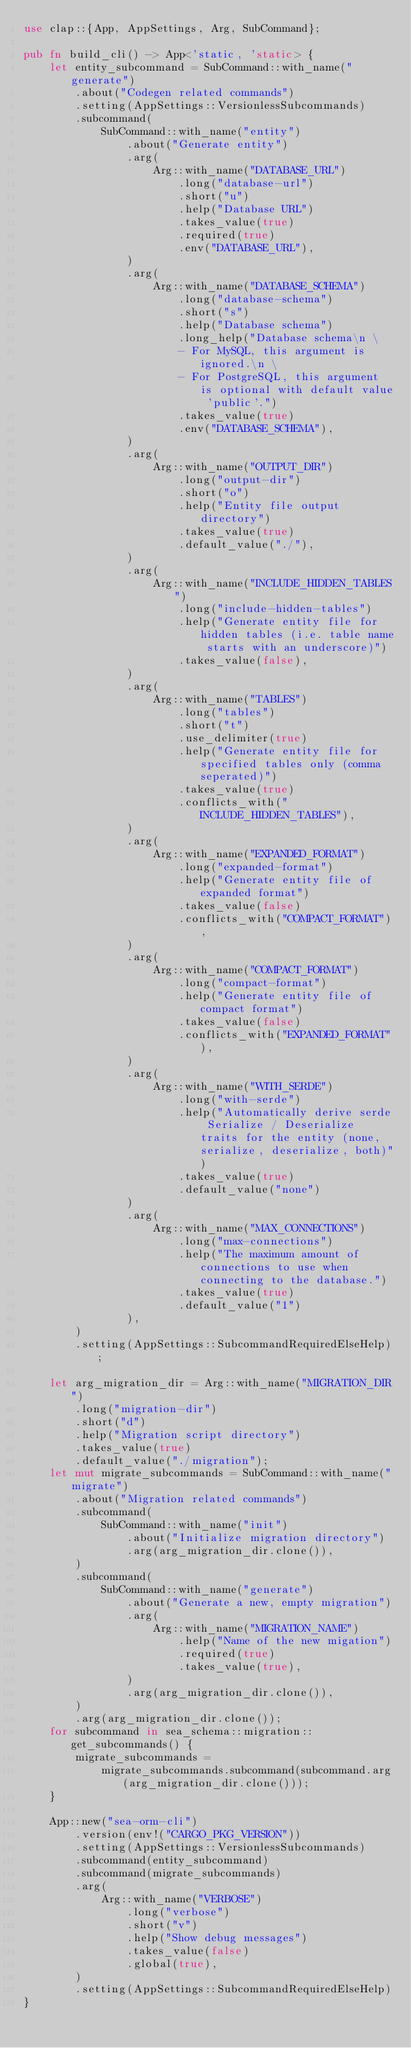Convert code to text. <code><loc_0><loc_0><loc_500><loc_500><_Rust_>use clap::{App, AppSettings, Arg, SubCommand};

pub fn build_cli() -> App<'static, 'static> {
    let entity_subcommand = SubCommand::with_name("generate")
        .about("Codegen related commands")
        .setting(AppSettings::VersionlessSubcommands)
        .subcommand(
            SubCommand::with_name("entity")
                .about("Generate entity")
                .arg(
                    Arg::with_name("DATABASE_URL")
                        .long("database-url")
                        .short("u")
                        .help("Database URL")
                        .takes_value(true)
                        .required(true)
                        .env("DATABASE_URL"),
                )
                .arg(
                    Arg::with_name("DATABASE_SCHEMA")
                        .long("database-schema")
                        .short("s")
                        .help("Database schema")
                        .long_help("Database schema\n \
                        - For MySQL, this argument is ignored.\n \
                        - For PostgreSQL, this argument is optional with default value 'public'.")
                        .takes_value(true)
                        .env("DATABASE_SCHEMA"),
                )
                .arg(
                    Arg::with_name("OUTPUT_DIR")
                        .long("output-dir")
                        .short("o")
                        .help("Entity file output directory")
                        .takes_value(true)
                        .default_value("./"),
                )
                .arg(
                    Arg::with_name("INCLUDE_HIDDEN_TABLES")
                        .long("include-hidden-tables")
                        .help("Generate entity file for hidden tables (i.e. table name starts with an underscore)")
                        .takes_value(false),
                )
                .arg(
                    Arg::with_name("TABLES")
                        .long("tables")
                        .short("t")
                        .use_delimiter(true)
                        .help("Generate entity file for specified tables only (comma seperated)")
                        .takes_value(true)
                        .conflicts_with("INCLUDE_HIDDEN_TABLES"),
                )
                .arg(
                    Arg::with_name("EXPANDED_FORMAT")
                        .long("expanded-format")
                        .help("Generate entity file of expanded format")
                        .takes_value(false)
                        .conflicts_with("COMPACT_FORMAT"),
                )
                .arg(
                    Arg::with_name("COMPACT_FORMAT")
                        .long("compact-format")
                        .help("Generate entity file of compact format")
                        .takes_value(false)
                        .conflicts_with("EXPANDED_FORMAT"),
                )
                .arg(
                    Arg::with_name("WITH_SERDE")
                        .long("with-serde")
                        .help("Automatically derive serde Serialize / Deserialize traits for the entity (none, serialize, deserialize, both)")
                        .takes_value(true)
                        .default_value("none")
                )
                .arg(
                    Arg::with_name("MAX_CONNECTIONS")
                        .long("max-connections")
                        .help("The maximum amount of connections to use when connecting to the database.")
                        .takes_value(true)
                        .default_value("1")
                ),
        )
        .setting(AppSettings::SubcommandRequiredElseHelp);

    let arg_migration_dir = Arg::with_name("MIGRATION_DIR")
        .long("migration-dir")
        .short("d")
        .help("Migration script directory")
        .takes_value(true)
        .default_value("./migration");
    let mut migrate_subcommands = SubCommand::with_name("migrate")
        .about("Migration related commands")
        .subcommand(
            SubCommand::with_name("init")
                .about("Initialize migration directory")
                .arg(arg_migration_dir.clone()),
        )
        .subcommand(
            SubCommand::with_name("generate")
                .about("Generate a new, empty migration")
                .arg(
                    Arg::with_name("MIGRATION_NAME")
                        .help("Name of the new migation")
                        .required(true)
                        .takes_value(true),
                )
                .arg(arg_migration_dir.clone()),
        )
        .arg(arg_migration_dir.clone());
    for subcommand in sea_schema::migration::get_subcommands() {
        migrate_subcommands =
            migrate_subcommands.subcommand(subcommand.arg(arg_migration_dir.clone()));
    }

    App::new("sea-orm-cli")
        .version(env!("CARGO_PKG_VERSION"))
        .setting(AppSettings::VersionlessSubcommands)
        .subcommand(entity_subcommand)
        .subcommand(migrate_subcommands)
        .arg(
            Arg::with_name("VERBOSE")
                .long("verbose")
                .short("v")
                .help("Show debug messages")
                .takes_value(false)
                .global(true),
        )
        .setting(AppSettings::SubcommandRequiredElseHelp)
}
</code> 